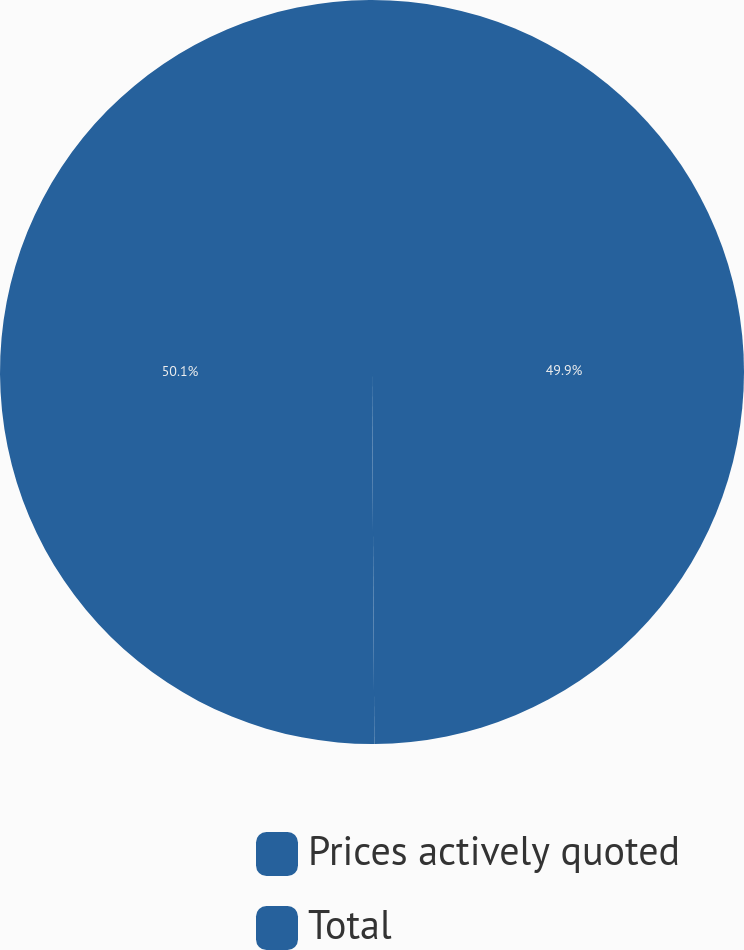Convert chart to OTSL. <chart><loc_0><loc_0><loc_500><loc_500><pie_chart><fcel>Prices actively quoted<fcel>Total<nl><fcel>49.9%<fcel>50.1%<nl></chart> 